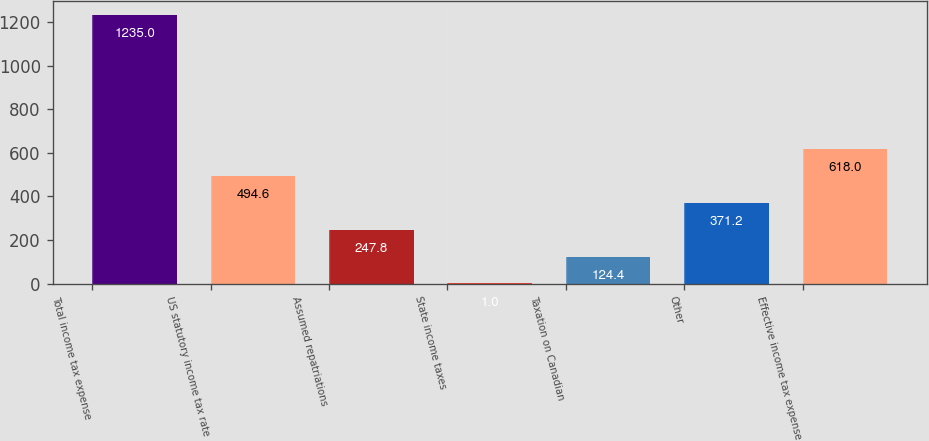<chart> <loc_0><loc_0><loc_500><loc_500><bar_chart><fcel>Total income tax expense<fcel>US statutory income tax rate<fcel>Assumed repatriations<fcel>State income taxes<fcel>Taxation on Canadian<fcel>Other<fcel>Effective income tax expense<nl><fcel>1235<fcel>494.6<fcel>247.8<fcel>1<fcel>124.4<fcel>371.2<fcel>618<nl></chart> 